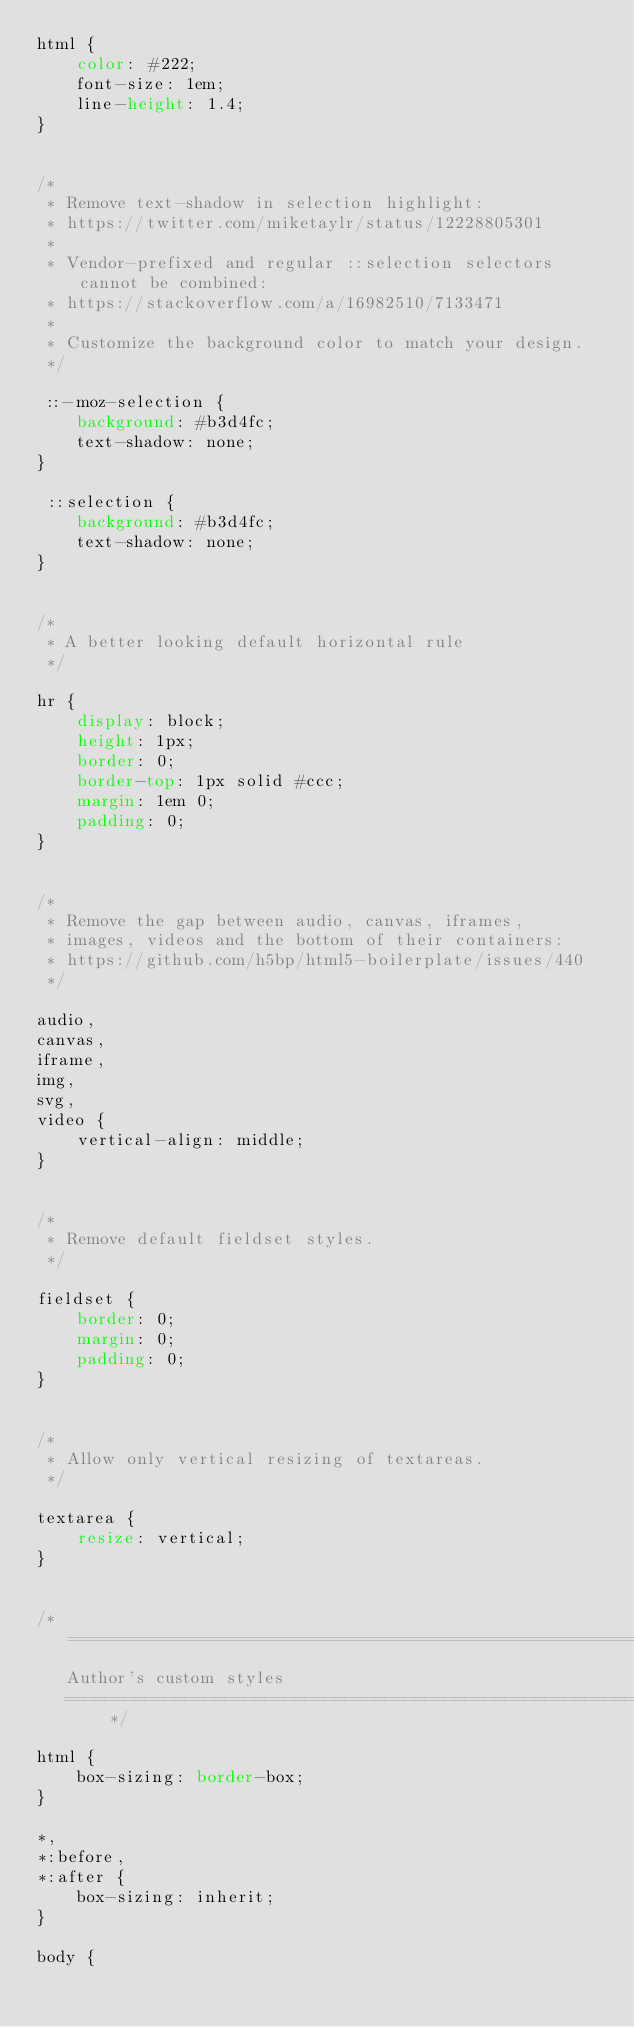<code> <loc_0><loc_0><loc_500><loc_500><_CSS_>html {
    color: #222;
    font-size: 1em;
    line-height: 1.4;
}


/*
 * Remove text-shadow in selection highlight:
 * https://twitter.com/miketaylr/status/12228805301
 *
 * Vendor-prefixed and regular ::selection selectors cannot be combined:
 * https://stackoverflow.com/a/16982510/7133471
 *
 * Customize the background color to match your design.
 */

 ::-moz-selection {
    background: #b3d4fc;
    text-shadow: none;
}

 ::selection {
    background: #b3d4fc;
    text-shadow: none;
}


/*
 * A better looking default horizontal rule
 */

hr {
    display: block;
    height: 1px;
    border: 0;
    border-top: 1px solid #ccc;
    margin: 1em 0;
    padding: 0;
}


/*
 * Remove the gap between audio, canvas, iframes,
 * images, videos and the bottom of their containers:
 * https://github.com/h5bp/html5-boilerplate/issues/440
 */

audio,
canvas,
iframe,
img,
svg,
video {
    vertical-align: middle;
}


/*
 * Remove default fieldset styles.
 */

fieldset {
    border: 0;
    margin: 0;
    padding: 0;
}


/*
 * Allow only vertical resizing of textareas.
 */

textarea {
    resize: vertical;
}


/* ==========================================================================
   Author's custom styles
   ========================================================================== */

html {
    box-sizing: border-box;
}

*,
*:before,
*:after {
    box-sizing: inherit;
}

body {</code> 